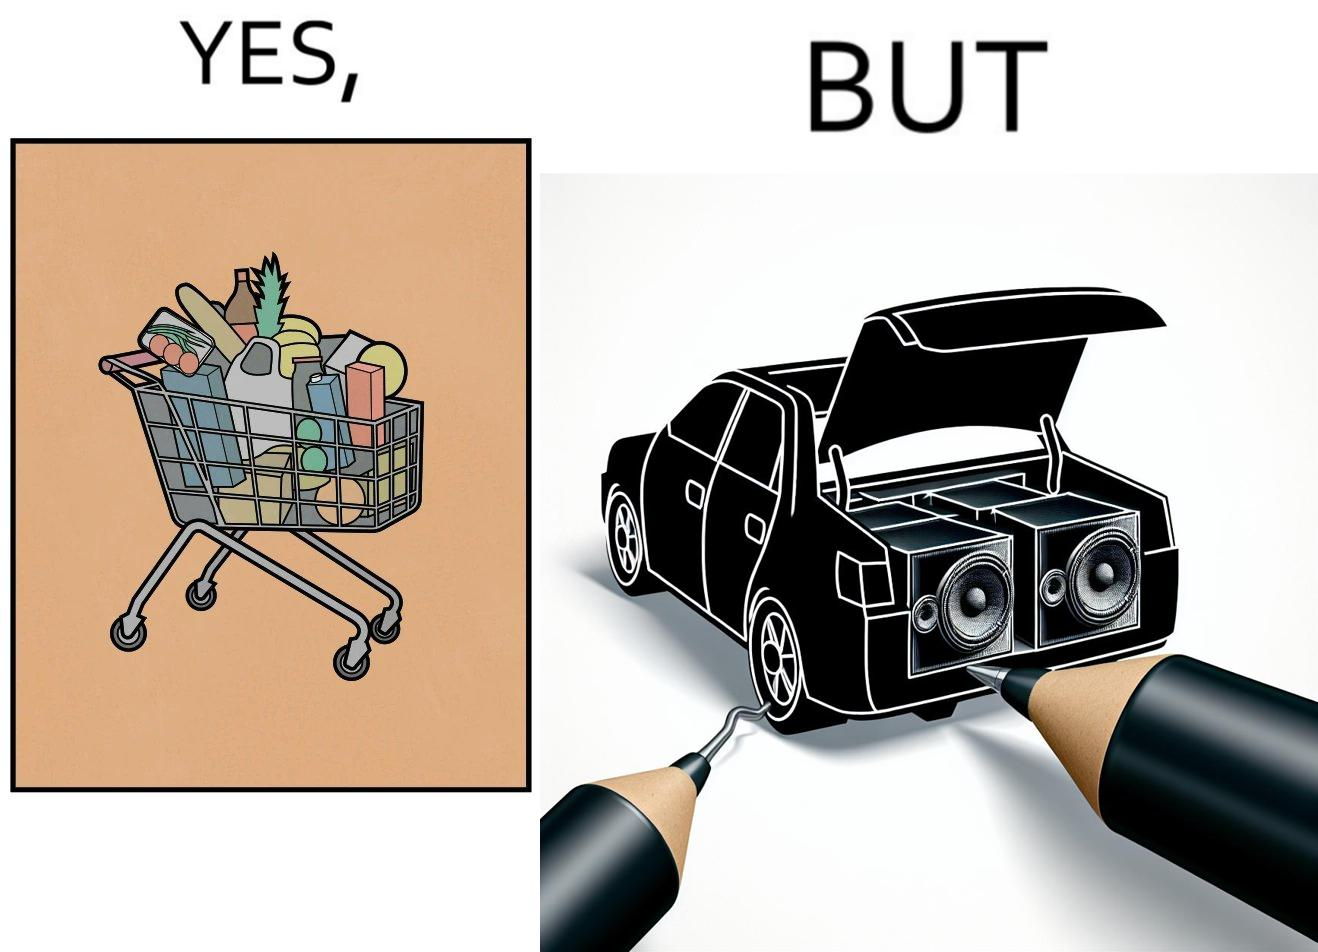Describe the content of this image. The image is ironic, because a car trunk was earlier designed to keep some extra luggage or things but people nowadays get speakers installed in the trunk which in turn reduces the space in the trunk and making it difficult for people to store the extra luggage in the trunk 